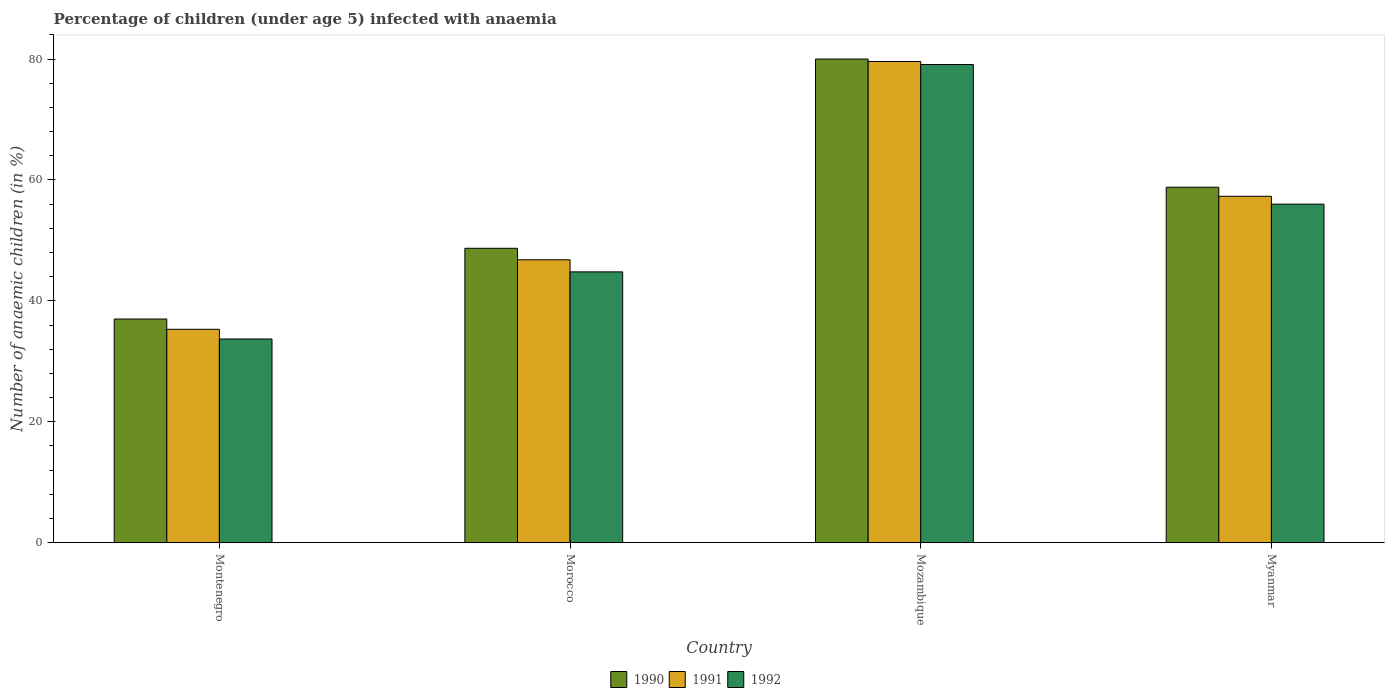How many different coloured bars are there?
Offer a very short reply. 3. Are the number of bars per tick equal to the number of legend labels?
Your response must be concise. Yes. Are the number of bars on each tick of the X-axis equal?
Offer a very short reply. Yes. How many bars are there on the 1st tick from the right?
Offer a terse response. 3. What is the label of the 4th group of bars from the left?
Offer a very short reply. Myanmar. Across all countries, what is the maximum percentage of children infected with anaemia in in 1992?
Make the answer very short. 79.1. In which country was the percentage of children infected with anaemia in in 1991 maximum?
Your answer should be very brief. Mozambique. In which country was the percentage of children infected with anaemia in in 1990 minimum?
Offer a terse response. Montenegro. What is the total percentage of children infected with anaemia in in 1992 in the graph?
Your response must be concise. 213.6. What is the difference between the percentage of children infected with anaemia in in 1991 in Morocco and that in Mozambique?
Give a very brief answer. -32.8. What is the difference between the percentage of children infected with anaemia in in 1990 in Montenegro and the percentage of children infected with anaemia in in 1992 in Myanmar?
Offer a very short reply. -19. What is the average percentage of children infected with anaemia in in 1992 per country?
Keep it short and to the point. 53.4. What is the difference between the percentage of children infected with anaemia in of/in 1990 and percentage of children infected with anaemia in of/in 1992 in Mozambique?
Your answer should be very brief. 0.9. What is the ratio of the percentage of children infected with anaemia in in 1992 in Morocco to that in Mozambique?
Your response must be concise. 0.57. Is the percentage of children infected with anaemia in in 1992 in Montenegro less than that in Mozambique?
Ensure brevity in your answer.  Yes. Is the difference between the percentage of children infected with anaemia in in 1990 in Montenegro and Mozambique greater than the difference between the percentage of children infected with anaemia in in 1992 in Montenegro and Mozambique?
Provide a short and direct response. Yes. What is the difference between the highest and the second highest percentage of children infected with anaemia in in 1992?
Give a very brief answer. 11.2. In how many countries, is the percentage of children infected with anaemia in in 1992 greater than the average percentage of children infected with anaemia in in 1992 taken over all countries?
Give a very brief answer. 2. Is the sum of the percentage of children infected with anaemia in in 1991 in Montenegro and Myanmar greater than the maximum percentage of children infected with anaemia in in 1992 across all countries?
Offer a very short reply. Yes. What does the 1st bar from the right in Myanmar represents?
Ensure brevity in your answer.  1992. How many bars are there?
Make the answer very short. 12. Are all the bars in the graph horizontal?
Make the answer very short. No. What is the difference between two consecutive major ticks on the Y-axis?
Give a very brief answer. 20. Does the graph contain any zero values?
Provide a succinct answer. No. How many legend labels are there?
Offer a terse response. 3. How are the legend labels stacked?
Keep it short and to the point. Horizontal. What is the title of the graph?
Your answer should be very brief. Percentage of children (under age 5) infected with anaemia. Does "1999" appear as one of the legend labels in the graph?
Provide a short and direct response. No. What is the label or title of the Y-axis?
Make the answer very short. Number of anaemic children (in %). What is the Number of anaemic children (in %) in 1991 in Montenegro?
Provide a succinct answer. 35.3. What is the Number of anaemic children (in %) of 1992 in Montenegro?
Give a very brief answer. 33.7. What is the Number of anaemic children (in %) in 1990 in Morocco?
Ensure brevity in your answer.  48.7. What is the Number of anaemic children (in %) of 1991 in Morocco?
Give a very brief answer. 46.8. What is the Number of anaemic children (in %) in 1992 in Morocco?
Your answer should be compact. 44.8. What is the Number of anaemic children (in %) of 1991 in Mozambique?
Your response must be concise. 79.6. What is the Number of anaemic children (in %) in 1992 in Mozambique?
Offer a terse response. 79.1. What is the Number of anaemic children (in %) of 1990 in Myanmar?
Your answer should be compact. 58.8. What is the Number of anaemic children (in %) in 1991 in Myanmar?
Your answer should be compact. 57.3. What is the Number of anaemic children (in %) in 1992 in Myanmar?
Offer a very short reply. 56. Across all countries, what is the maximum Number of anaemic children (in %) of 1990?
Offer a terse response. 80. Across all countries, what is the maximum Number of anaemic children (in %) in 1991?
Provide a short and direct response. 79.6. Across all countries, what is the maximum Number of anaemic children (in %) in 1992?
Your response must be concise. 79.1. Across all countries, what is the minimum Number of anaemic children (in %) of 1991?
Make the answer very short. 35.3. Across all countries, what is the minimum Number of anaemic children (in %) in 1992?
Offer a very short reply. 33.7. What is the total Number of anaemic children (in %) of 1990 in the graph?
Ensure brevity in your answer.  224.5. What is the total Number of anaemic children (in %) of 1991 in the graph?
Give a very brief answer. 219. What is the total Number of anaemic children (in %) in 1992 in the graph?
Provide a succinct answer. 213.6. What is the difference between the Number of anaemic children (in %) in 1990 in Montenegro and that in Morocco?
Your answer should be compact. -11.7. What is the difference between the Number of anaemic children (in %) in 1992 in Montenegro and that in Morocco?
Keep it short and to the point. -11.1. What is the difference between the Number of anaemic children (in %) in 1990 in Montenegro and that in Mozambique?
Your response must be concise. -43. What is the difference between the Number of anaemic children (in %) in 1991 in Montenegro and that in Mozambique?
Keep it short and to the point. -44.3. What is the difference between the Number of anaemic children (in %) of 1992 in Montenegro and that in Mozambique?
Offer a terse response. -45.4. What is the difference between the Number of anaemic children (in %) in 1990 in Montenegro and that in Myanmar?
Provide a succinct answer. -21.8. What is the difference between the Number of anaemic children (in %) in 1992 in Montenegro and that in Myanmar?
Your answer should be compact. -22.3. What is the difference between the Number of anaemic children (in %) in 1990 in Morocco and that in Mozambique?
Your answer should be compact. -31.3. What is the difference between the Number of anaemic children (in %) of 1991 in Morocco and that in Mozambique?
Your response must be concise. -32.8. What is the difference between the Number of anaemic children (in %) of 1992 in Morocco and that in Mozambique?
Offer a very short reply. -34.3. What is the difference between the Number of anaemic children (in %) of 1990 in Morocco and that in Myanmar?
Your answer should be very brief. -10.1. What is the difference between the Number of anaemic children (in %) of 1991 in Morocco and that in Myanmar?
Your response must be concise. -10.5. What is the difference between the Number of anaemic children (in %) in 1990 in Mozambique and that in Myanmar?
Your answer should be very brief. 21.2. What is the difference between the Number of anaemic children (in %) of 1991 in Mozambique and that in Myanmar?
Ensure brevity in your answer.  22.3. What is the difference between the Number of anaemic children (in %) in 1992 in Mozambique and that in Myanmar?
Ensure brevity in your answer.  23.1. What is the difference between the Number of anaemic children (in %) in 1990 in Montenegro and the Number of anaemic children (in %) in 1991 in Mozambique?
Offer a terse response. -42.6. What is the difference between the Number of anaemic children (in %) of 1990 in Montenegro and the Number of anaemic children (in %) of 1992 in Mozambique?
Your answer should be very brief. -42.1. What is the difference between the Number of anaemic children (in %) in 1991 in Montenegro and the Number of anaemic children (in %) in 1992 in Mozambique?
Offer a terse response. -43.8. What is the difference between the Number of anaemic children (in %) of 1990 in Montenegro and the Number of anaemic children (in %) of 1991 in Myanmar?
Give a very brief answer. -20.3. What is the difference between the Number of anaemic children (in %) in 1990 in Montenegro and the Number of anaemic children (in %) in 1992 in Myanmar?
Provide a succinct answer. -19. What is the difference between the Number of anaemic children (in %) in 1991 in Montenegro and the Number of anaemic children (in %) in 1992 in Myanmar?
Your answer should be compact. -20.7. What is the difference between the Number of anaemic children (in %) of 1990 in Morocco and the Number of anaemic children (in %) of 1991 in Mozambique?
Provide a short and direct response. -30.9. What is the difference between the Number of anaemic children (in %) of 1990 in Morocco and the Number of anaemic children (in %) of 1992 in Mozambique?
Your response must be concise. -30.4. What is the difference between the Number of anaemic children (in %) of 1991 in Morocco and the Number of anaemic children (in %) of 1992 in Mozambique?
Your answer should be compact. -32.3. What is the difference between the Number of anaemic children (in %) of 1990 in Morocco and the Number of anaemic children (in %) of 1992 in Myanmar?
Ensure brevity in your answer.  -7.3. What is the difference between the Number of anaemic children (in %) of 1991 in Morocco and the Number of anaemic children (in %) of 1992 in Myanmar?
Your answer should be compact. -9.2. What is the difference between the Number of anaemic children (in %) in 1990 in Mozambique and the Number of anaemic children (in %) in 1991 in Myanmar?
Your answer should be compact. 22.7. What is the difference between the Number of anaemic children (in %) of 1990 in Mozambique and the Number of anaemic children (in %) of 1992 in Myanmar?
Offer a terse response. 24. What is the difference between the Number of anaemic children (in %) in 1991 in Mozambique and the Number of anaemic children (in %) in 1992 in Myanmar?
Provide a short and direct response. 23.6. What is the average Number of anaemic children (in %) of 1990 per country?
Offer a terse response. 56.12. What is the average Number of anaemic children (in %) of 1991 per country?
Make the answer very short. 54.75. What is the average Number of anaemic children (in %) in 1992 per country?
Keep it short and to the point. 53.4. What is the difference between the Number of anaemic children (in %) in 1990 and Number of anaemic children (in %) in 1992 in Montenegro?
Offer a very short reply. 3.3. What is the difference between the Number of anaemic children (in %) in 1991 and Number of anaemic children (in %) in 1992 in Montenegro?
Provide a short and direct response. 1.6. What is the difference between the Number of anaemic children (in %) in 1990 and Number of anaemic children (in %) in 1992 in Mozambique?
Provide a succinct answer. 0.9. What is the difference between the Number of anaemic children (in %) in 1990 and Number of anaemic children (in %) in 1991 in Myanmar?
Make the answer very short. 1.5. What is the difference between the Number of anaemic children (in %) in 1990 and Number of anaemic children (in %) in 1992 in Myanmar?
Keep it short and to the point. 2.8. What is the ratio of the Number of anaemic children (in %) of 1990 in Montenegro to that in Morocco?
Ensure brevity in your answer.  0.76. What is the ratio of the Number of anaemic children (in %) of 1991 in Montenegro to that in Morocco?
Your answer should be very brief. 0.75. What is the ratio of the Number of anaemic children (in %) in 1992 in Montenegro to that in Morocco?
Make the answer very short. 0.75. What is the ratio of the Number of anaemic children (in %) in 1990 in Montenegro to that in Mozambique?
Ensure brevity in your answer.  0.46. What is the ratio of the Number of anaemic children (in %) of 1991 in Montenegro to that in Mozambique?
Offer a very short reply. 0.44. What is the ratio of the Number of anaemic children (in %) in 1992 in Montenegro to that in Mozambique?
Provide a short and direct response. 0.43. What is the ratio of the Number of anaemic children (in %) in 1990 in Montenegro to that in Myanmar?
Your answer should be compact. 0.63. What is the ratio of the Number of anaemic children (in %) in 1991 in Montenegro to that in Myanmar?
Offer a terse response. 0.62. What is the ratio of the Number of anaemic children (in %) in 1992 in Montenegro to that in Myanmar?
Provide a succinct answer. 0.6. What is the ratio of the Number of anaemic children (in %) of 1990 in Morocco to that in Mozambique?
Provide a short and direct response. 0.61. What is the ratio of the Number of anaemic children (in %) in 1991 in Morocco to that in Mozambique?
Ensure brevity in your answer.  0.59. What is the ratio of the Number of anaemic children (in %) in 1992 in Morocco to that in Mozambique?
Ensure brevity in your answer.  0.57. What is the ratio of the Number of anaemic children (in %) in 1990 in Morocco to that in Myanmar?
Make the answer very short. 0.83. What is the ratio of the Number of anaemic children (in %) of 1991 in Morocco to that in Myanmar?
Make the answer very short. 0.82. What is the ratio of the Number of anaemic children (in %) in 1990 in Mozambique to that in Myanmar?
Keep it short and to the point. 1.36. What is the ratio of the Number of anaemic children (in %) in 1991 in Mozambique to that in Myanmar?
Your answer should be very brief. 1.39. What is the ratio of the Number of anaemic children (in %) in 1992 in Mozambique to that in Myanmar?
Make the answer very short. 1.41. What is the difference between the highest and the second highest Number of anaemic children (in %) of 1990?
Your answer should be compact. 21.2. What is the difference between the highest and the second highest Number of anaemic children (in %) in 1991?
Keep it short and to the point. 22.3. What is the difference between the highest and the second highest Number of anaemic children (in %) of 1992?
Provide a short and direct response. 23.1. What is the difference between the highest and the lowest Number of anaemic children (in %) in 1991?
Your answer should be very brief. 44.3. What is the difference between the highest and the lowest Number of anaemic children (in %) in 1992?
Offer a terse response. 45.4. 